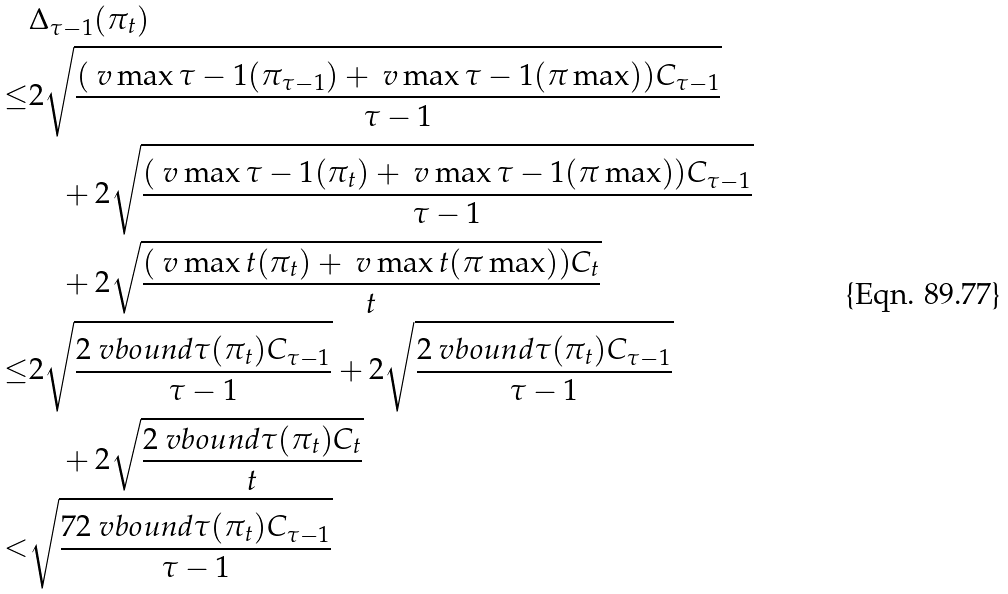<formula> <loc_0><loc_0><loc_500><loc_500>& \Delta _ { \tau - 1 } ( \pi _ { t } ) \\ \leq & 2 \sqrt { \frac { ( \ v \max { \tau - 1 } ( \pi _ { \tau - 1 } ) + \ v \max { \tau - 1 } ( \pi \max ) ) C _ { \tau - 1 } } { \tau - 1 } } \\ & \quad + 2 \sqrt { \frac { ( \ v \max { \tau - 1 } ( \pi _ { t } ) + \ v \max { \tau - 1 } ( \pi \max ) ) C _ { \tau - 1 } } { \tau - 1 } } \\ & \quad + 2 \sqrt { \frac { ( \ v \max { t } ( \pi _ { t } ) + \ v \max { t } ( \pi \max ) ) C _ { t } } { t } } \\ \leq & 2 \sqrt { \frac { 2 \ v b o u n d { \tau } ( \pi _ { t } ) C _ { \tau - 1 } } { \tau - 1 } } + 2 \sqrt { \frac { 2 \ v b o u n d { \tau } ( \pi _ { t } ) C _ { \tau - 1 } } { \tau - 1 } } \\ & \quad + 2 \sqrt { \frac { 2 \ v b o u n d { \tau } ( \pi _ { t } ) C _ { t } } { t } } \\ < & \sqrt { \frac { 7 2 \ v b o u n d { \tau } ( \pi _ { t } ) C _ { \tau - 1 } } { \tau - 1 } }</formula> 